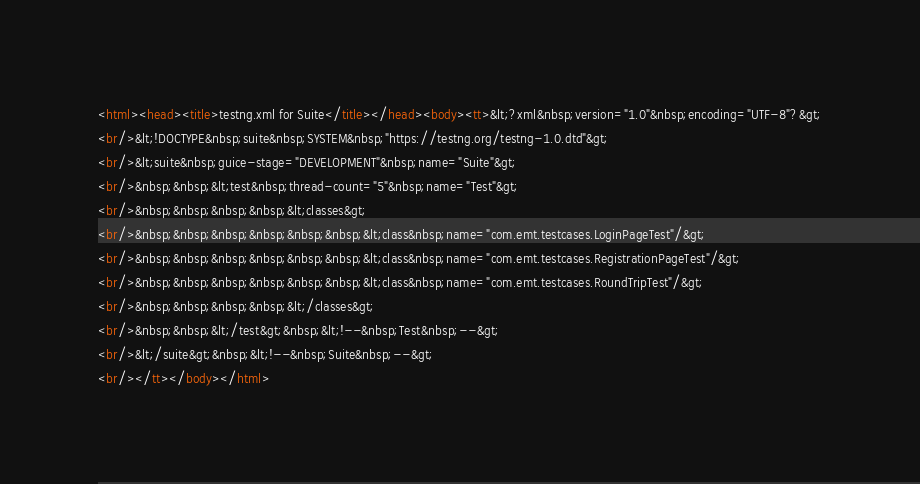Convert code to text. <code><loc_0><loc_0><loc_500><loc_500><_HTML_><html><head><title>testng.xml for Suite</title></head><body><tt>&lt;?xml&nbsp;version="1.0"&nbsp;encoding="UTF-8"?&gt;<br/>&lt;!DOCTYPE&nbsp;suite&nbsp;SYSTEM&nbsp;"https://testng.org/testng-1.0.dtd"&gt;<br/>&lt;suite&nbsp;guice-stage="DEVELOPMENT"&nbsp;name="Suite"&gt;<br/>&nbsp;&nbsp;&lt;test&nbsp;thread-count="5"&nbsp;name="Test"&gt;<br/>&nbsp;&nbsp;&nbsp;&nbsp;&lt;classes&gt;<br/>&nbsp;&nbsp;&nbsp;&nbsp;&nbsp;&nbsp;&lt;class&nbsp;name="com.emt.testcases.LoginPageTest"/&gt;<br/>&nbsp;&nbsp;&nbsp;&nbsp;&nbsp;&nbsp;&lt;class&nbsp;name="com.emt.testcases.RegistrationPageTest"/&gt;<br/>&nbsp;&nbsp;&nbsp;&nbsp;&nbsp;&nbsp;&lt;class&nbsp;name="com.emt.testcases.RoundTripTest"/&gt;<br/>&nbsp;&nbsp;&nbsp;&nbsp;&lt;/classes&gt;<br/>&nbsp;&nbsp;&lt;/test&gt;&nbsp;&lt;!--&nbsp;Test&nbsp;--&gt;<br/>&lt;/suite&gt;&nbsp;&lt;!--&nbsp;Suite&nbsp;--&gt;<br/></tt></body></html></code> 